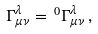<formula> <loc_0><loc_0><loc_500><loc_500>\Gamma ^ { \lambda } _ { \mu \nu } = \, ^ { 0 } \Gamma ^ { \lambda } _ { \mu \nu } \, ,</formula> 